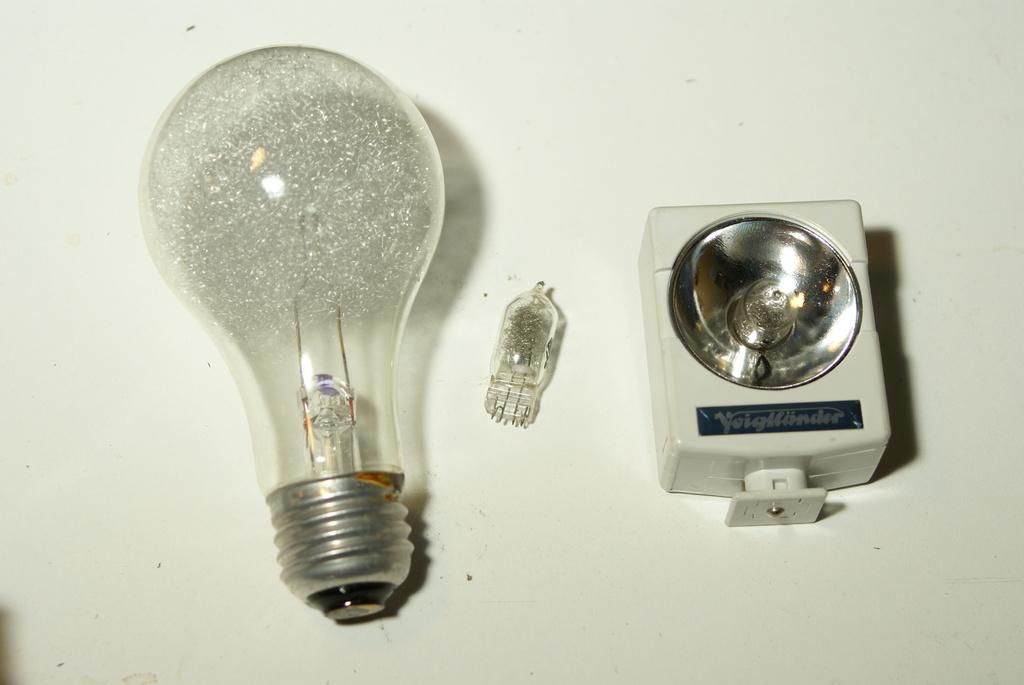How many bulbs are visible in the image? There are three bulbs in the image. Where might the bulbs be located? The bulbs may be on a table. What type of setting is depicted in the image? The image is taken in a room. What type of pets can be seen playing with copper wires in the image? There are no pets or copper wires present in the image. 